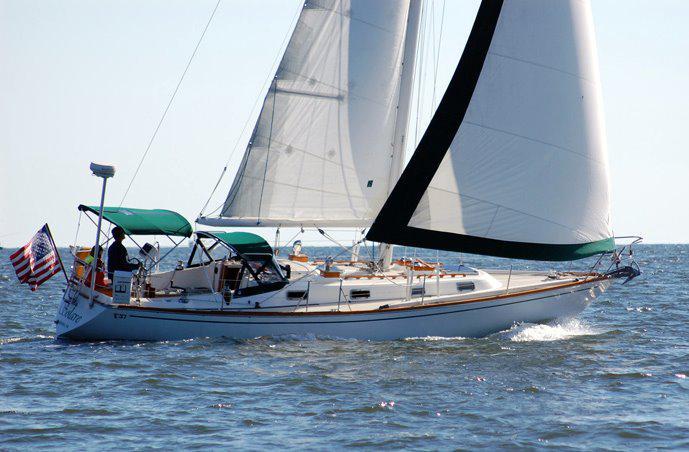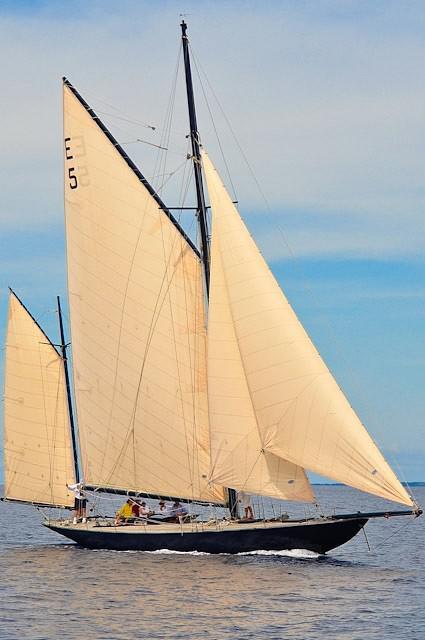The first image is the image on the left, the second image is the image on the right. Assess this claim about the two images: "The left and right image contains the same number of sailboats facing right.". Correct or not? Answer yes or no. Yes. 